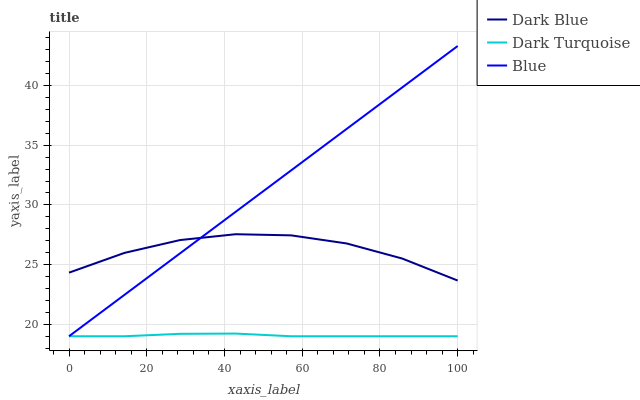Does Dark Turquoise have the minimum area under the curve?
Answer yes or no. Yes. Does Blue have the maximum area under the curve?
Answer yes or no. Yes. Does Dark Blue have the minimum area under the curve?
Answer yes or no. No. Does Dark Blue have the maximum area under the curve?
Answer yes or no. No. Is Blue the smoothest?
Answer yes or no. Yes. Is Dark Blue the roughest?
Answer yes or no. Yes. Is Dark Turquoise the smoothest?
Answer yes or no. No. Is Dark Turquoise the roughest?
Answer yes or no. No. Does Blue have the lowest value?
Answer yes or no. Yes. Does Dark Blue have the lowest value?
Answer yes or no. No. Does Blue have the highest value?
Answer yes or no. Yes. Does Dark Blue have the highest value?
Answer yes or no. No. Is Dark Turquoise less than Dark Blue?
Answer yes or no. Yes. Is Dark Blue greater than Dark Turquoise?
Answer yes or no. Yes. Does Dark Blue intersect Blue?
Answer yes or no. Yes. Is Dark Blue less than Blue?
Answer yes or no. No. Is Dark Blue greater than Blue?
Answer yes or no. No. Does Dark Turquoise intersect Dark Blue?
Answer yes or no. No. 